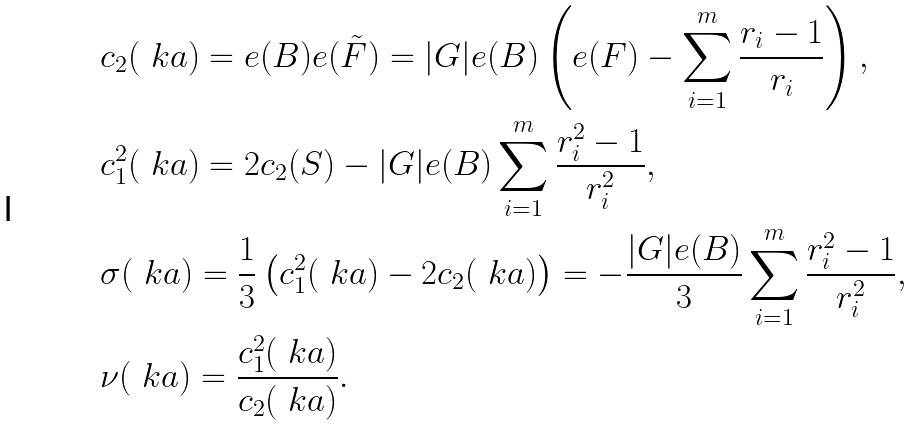<formula> <loc_0><loc_0><loc_500><loc_500>& c _ { 2 } ( \ k a ) = e ( B ) e ( \tilde { F } ) = | G | e ( B ) \left ( e ( F ) - \sum _ { i = 1 } ^ { m } \frac { r _ { i } - 1 } { r _ { i } } \right ) , \\ & c _ { 1 } ^ { 2 } ( \ k a ) = 2 c _ { 2 } ( S ) - | G | e ( B ) \sum _ { i = 1 } ^ { m } \frac { r _ { i } ^ { 2 } - 1 } { r _ { i } ^ { 2 } } , \\ & \sigma ( \ k a ) = \frac { 1 } { 3 } \left ( c _ { 1 } ^ { 2 } ( \ k a ) - 2 c _ { 2 } ( \ k a ) \right ) = - \frac { | G | e ( B ) } { 3 } \sum _ { i = 1 } ^ { m } \frac { r _ { i } ^ { 2 } - 1 } { r _ { i } ^ { 2 } } , \\ & \nu ( \ k a ) = \frac { c _ { 1 } ^ { 2 } ( \ k a ) } { c _ { 2 } ( \ k a ) } .</formula> 